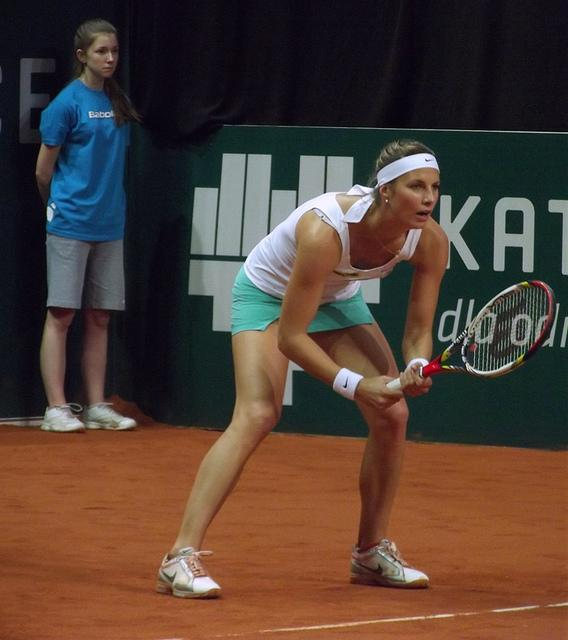What is she ready to do? Please explain your reasoning. swing. The tennis player is getting ready to swing and hit the ball. 